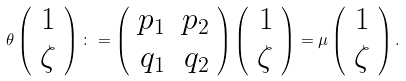<formula> <loc_0><loc_0><loc_500><loc_500>\theta \left ( \begin{array} { r } 1 \\ \zeta \end{array} \right ) \colon = \left ( \begin{array} { r r } p _ { 1 } & p _ { 2 } \\ q _ { 1 } & q _ { 2 } \end{array} \right ) \left ( \begin{array} { r } 1 \\ \zeta \end{array} \right ) = \mu \left ( \begin{array} { r r } 1 \\ \zeta \end{array} \right ) .</formula> 